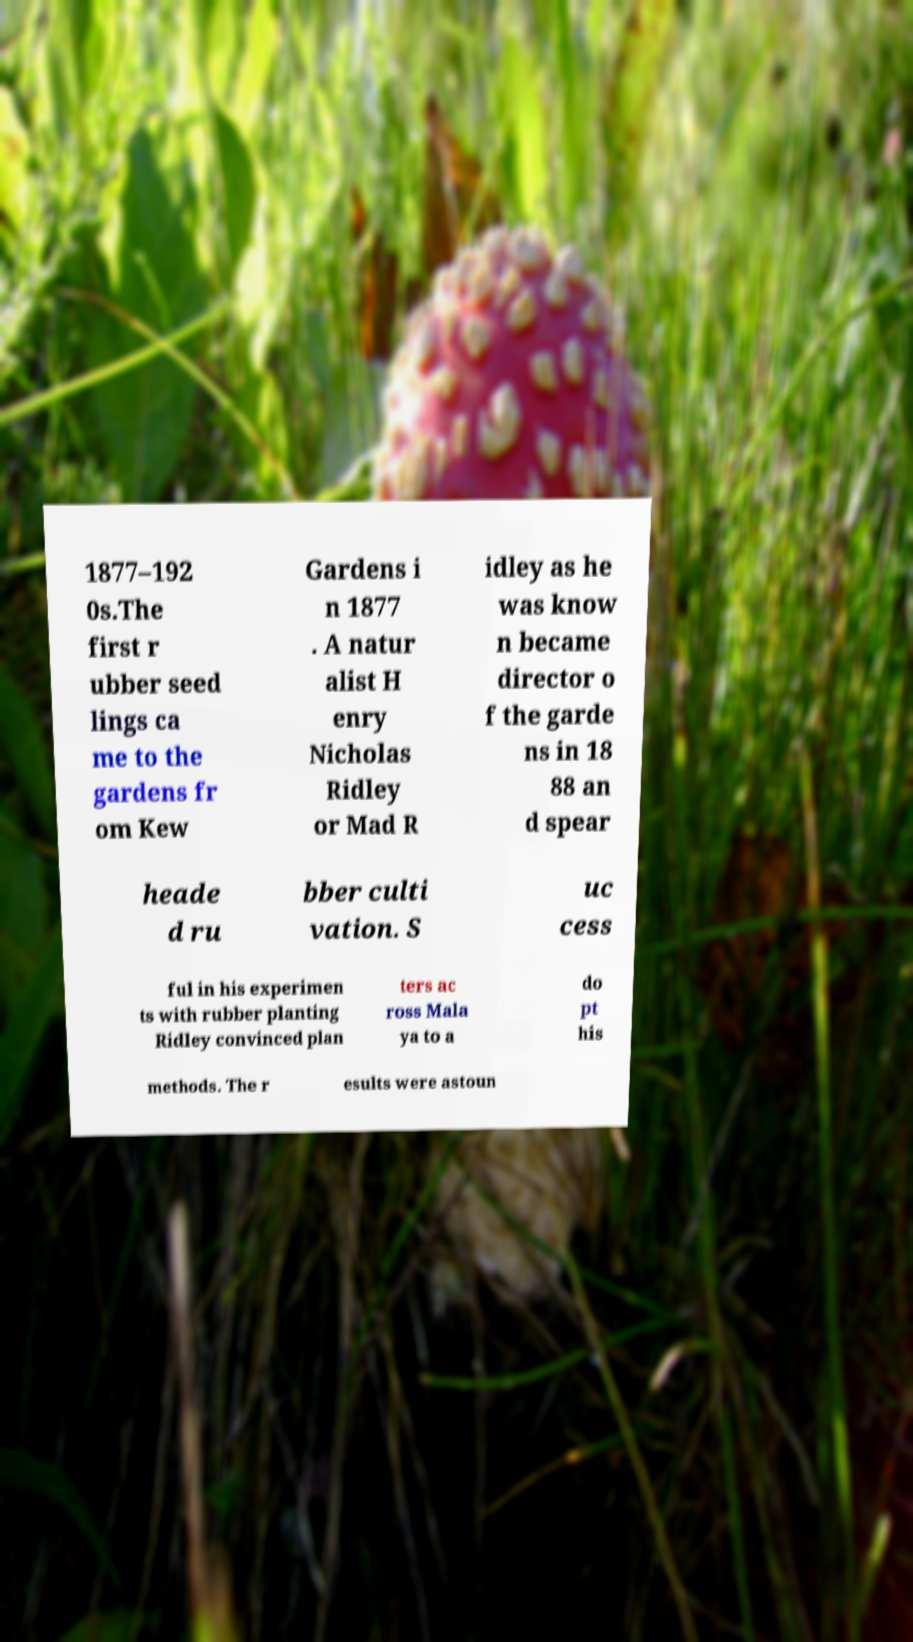There's text embedded in this image that I need extracted. Can you transcribe it verbatim? 1877–192 0s.The first r ubber seed lings ca me to the gardens fr om Kew Gardens i n 1877 . A natur alist H enry Nicholas Ridley or Mad R idley as he was know n became director o f the garde ns in 18 88 an d spear heade d ru bber culti vation. S uc cess ful in his experimen ts with rubber planting Ridley convinced plan ters ac ross Mala ya to a do pt his methods. The r esults were astoun 